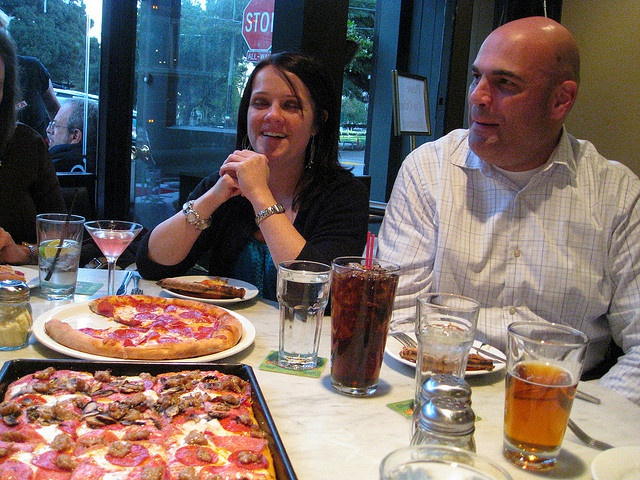Describe the objects in this image and their specific colors. I can see dining table in darkblue, lightgray, black, tan, and lightpink tones, people in darkblue, darkgray, gray, maroon, and tan tones, people in darkblue, black, brown, maroon, and tan tones, pizza in darkblue, lightpink, tan, salmon, and white tones, and cup in darkblue, red, darkgray, and gray tones in this image. 